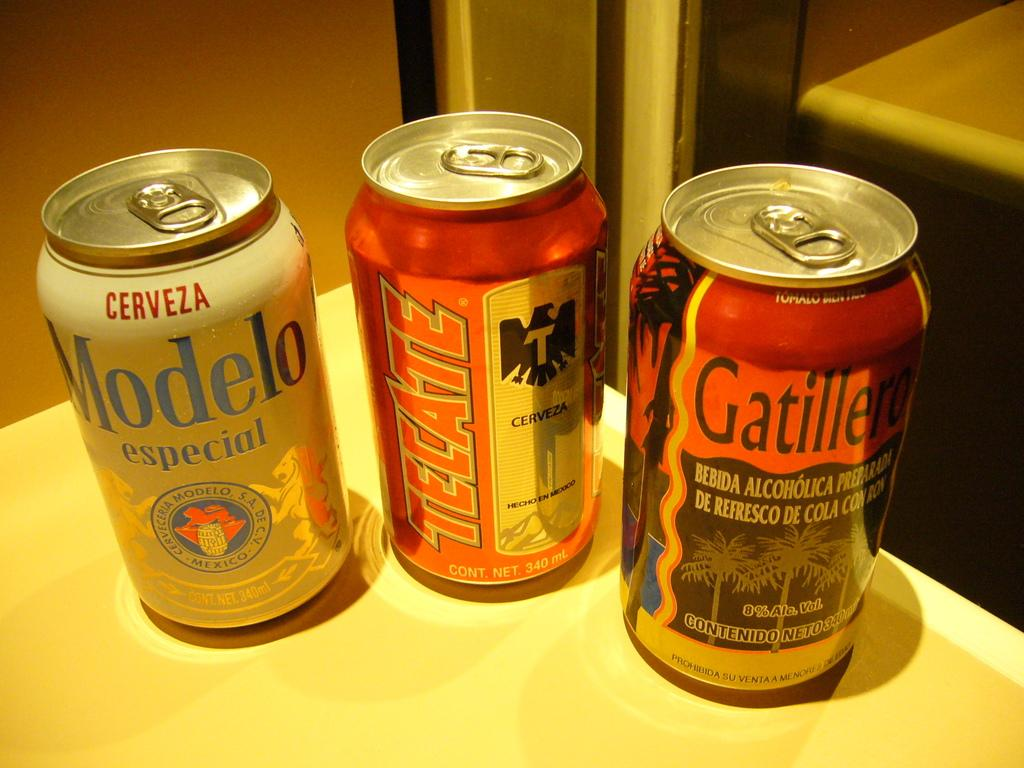<image>
Relay a brief, clear account of the picture shown. Several beers on the counter including a Modelo and a Tecate. 